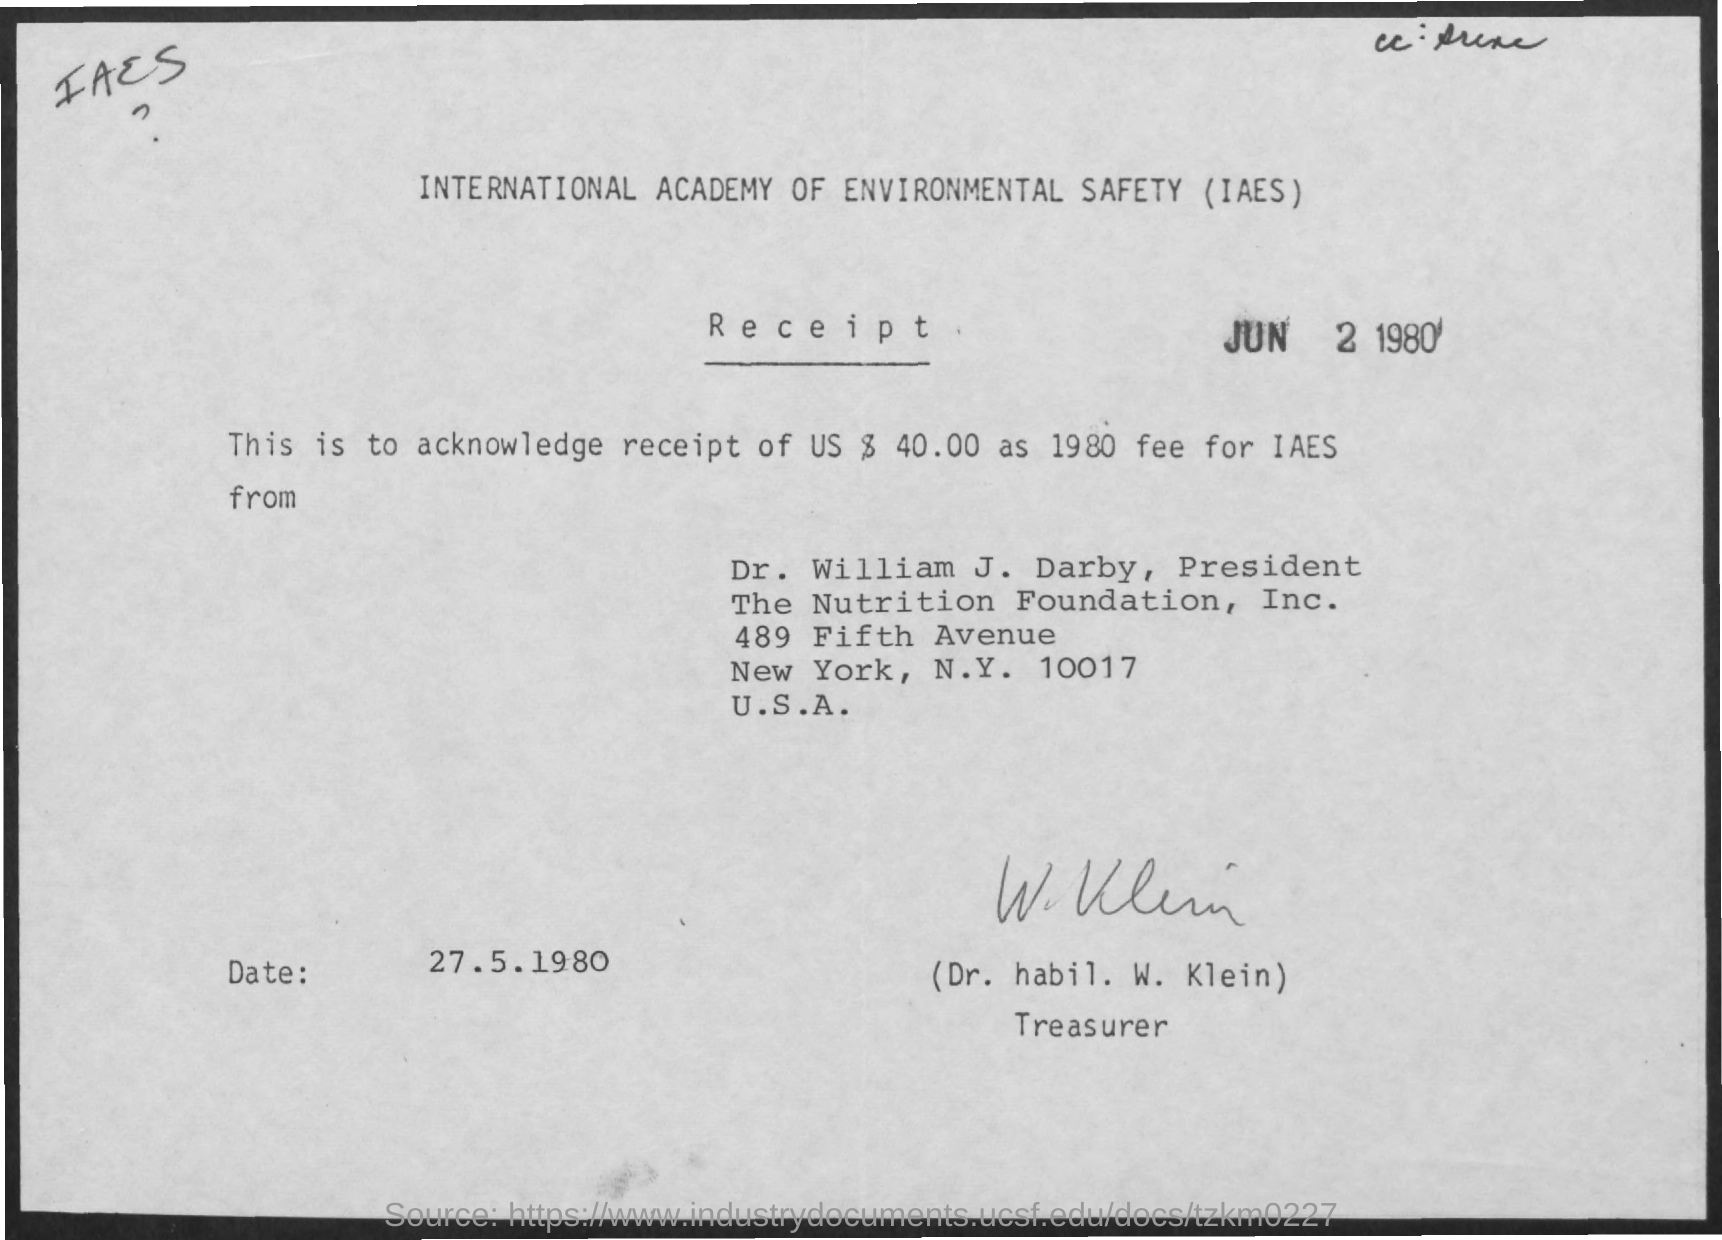Indicate a few pertinent items in this graphic. The Treasurer mentioned in the document is Dr. Habil. W. Klein. The President of the Nutrition Foundation is Dr. William J. Darby. 